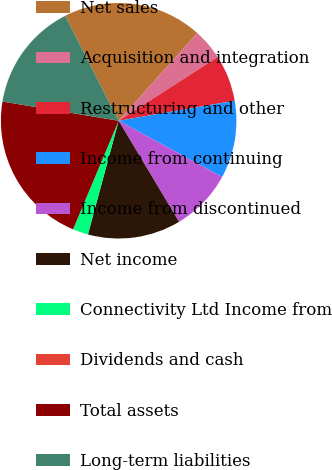Convert chart to OTSL. <chart><loc_0><loc_0><loc_500><loc_500><pie_chart><fcel>Net sales<fcel>Acquisition and integration<fcel>Restructuring and other<fcel>Income from continuing<fcel>Income from discontinued<fcel>Net income<fcel>Connectivity Ltd Income from<fcel>Dividends and cash<fcel>Total assets<fcel>Long-term liabilities<nl><fcel>19.15%<fcel>4.26%<fcel>6.38%<fcel>10.64%<fcel>8.51%<fcel>12.77%<fcel>2.13%<fcel>0.0%<fcel>21.28%<fcel>14.89%<nl></chart> 